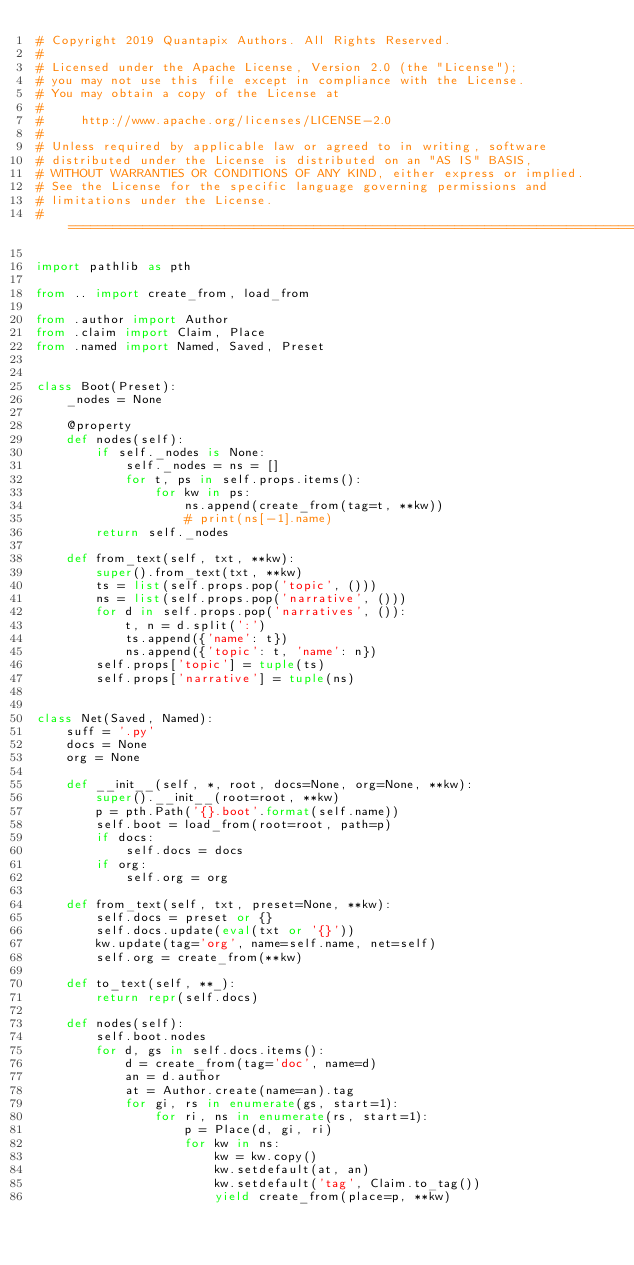Convert code to text. <code><loc_0><loc_0><loc_500><loc_500><_Python_># Copyright 2019 Quantapix Authors. All Rights Reserved.
#
# Licensed under the Apache License, Version 2.0 (the "License");
# you may not use this file except in compliance with the License.
# You may obtain a copy of the License at
#
#     http://www.apache.org/licenses/LICENSE-2.0
#
# Unless required by applicable law or agreed to in writing, software
# distributed under the License is distributed on an "AS IS" BASIS,
# WITHOUT WARRANTIES OR CONDITIONS OF ANY KIND, either express or implied.
# See the License for the specific language governing permissions and
# limitations under the License.
# =============================================================================

import pathlib as pth

from .. import create_from, load_from

from .author import Author
from .claim import Claim, Place
from .named import Named, Saved, Preset


class Boot(Preset):
    _nodes = None

    @property
    def nodes(self):
        if self._nodes is None:
            self._nodes = ns = []
            for t, ps in self.props.items():
                for kw in ps:
                    ns.append(create_from(tag=t, **kw))
                    # print(ns[-1].name)
        return self._nodes

    def from_text(self, txt, **kw):
        super().from_text(txt, **kw)
        ts = list(self.props.pop('topic', ()))
        ns = list(self.props.pop('narrative', ()))
        for d in self.props.pop('narratives', ()):
            t, n = d.split(':')
            ts.append({'name': t})
            ns.append({'topic': t, 'name': n})
        self.props['topic'] = tuple(ts)
        self.props['narrative'] = tuple(ns)


class Net(Saved, Named):
    suff = '.py'
    docs = None
    org = None

    def __init__(self, *, root, docs=None, org=None, **kw):
        super().__init__(root=root, **kw)
        p = pth.Path('{}.boot'.format(self.name))
        self.boot = load_from(root=root, path=p)
        if docs:
            self.docs = docs
        if org:
            self.org = org

    def from_text(self, txt, preset=None, **kw):
        self.docs = preset or {}
        self.docs.update(eval(txt or '{}'))
        kw.update(tag='org', name=self.name, net=self)
        self.org = create_from(**kw)

    def to_text(self, **_):
        return repr(self.docs)

    def nodes(self):
        self.boot.nodes
        for d, gs in self.docs.items():
            d = create_from(tag='doc', name=d)
            an = d.author
            at = Author.create(name=an).tag
            for gi, rs in enumerate(gs, start=1):
                for ri, ns in enumerate(rs, start=1):
                    p = Place(d, gi, ri)
                    for kw in ns:
                        kw = kw.copy()
                        kw.setdefault(at, an)
                        kw.setdefault('tag', Claim.to_tag())
                        yield create_from(place=p, **kw)
</code> 